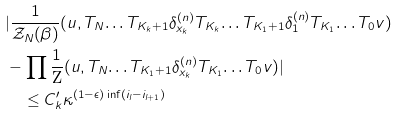Convert formula to latex. <formula><loc_0><loc_0><loc_500><loc_500>& | \frac { 1 } { \mathcal { Z } _ { N } ( \beta ) } ( u , T _ { N } \text {\dots} T _ { K _ { k } + 1 } \delta _ { x _ { k } } ^ { ( n ) } T _ { K _ { k } } \text {\dots} T _ { K _ { 1 } + 1 } \delta _ { 1 } ^ { ( n ) } T _ { K _ { 1 } } \text {\dots} T _ { 0 } v ) \\ & - \prod \frac { 1 } { \text {Z} } ( u , T _ { N } \text {\dots} T _ { K _ { 1 } + 1 } \delta _ { x _ { k } } ^ { ( n ) } T _ { K _ { 1 } } \text {\dots} T _ { 0 } v ) | \\ & \quad \leq C ^ { \prime } _ { k } \kappa ^ { ( 1 - \epsilon ) \inf ( i _ { l } - i _ { l + 1 } ) }</formula> 